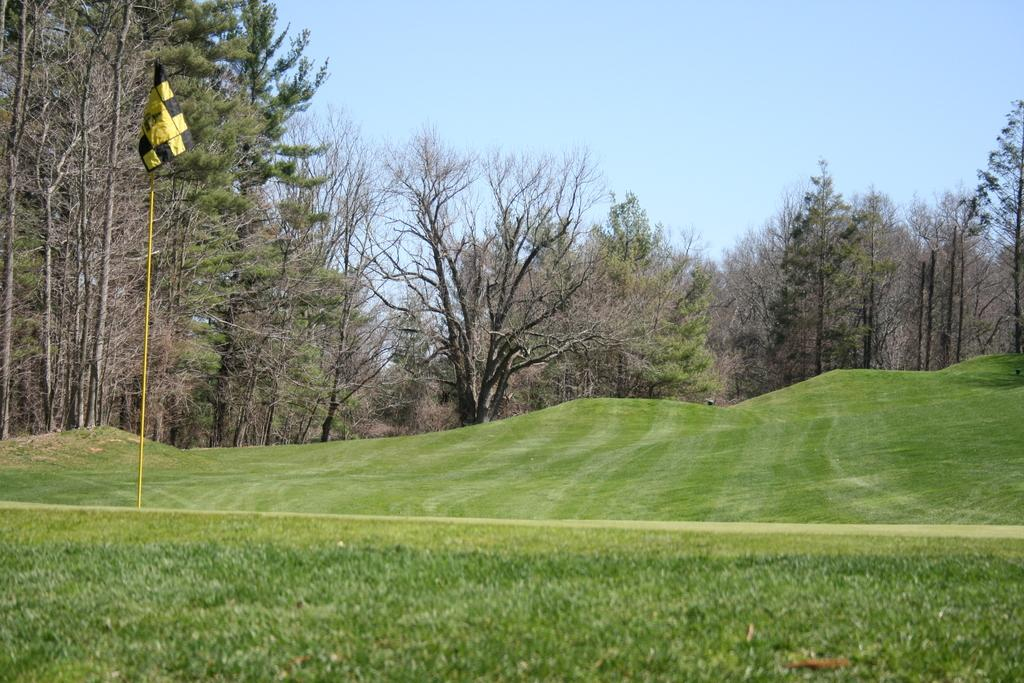Where was the picture taken? The picture was clicked outside. What can be seen in the foreground of the image? There is green grass in the foreground. What is located on the left side of the image? There is a flag on the left side, attached to a pole. What is visible in the background of the image? There is a sky visible in the background, and there are trees in the background. What type of argument is taking place between the dolls in the image? There are no dolls present in the image, so there cannot be an argument between them. 